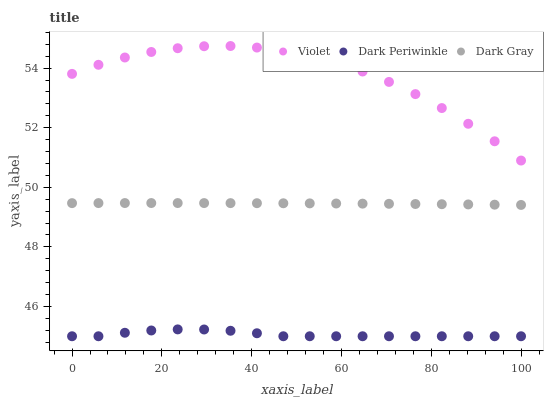Does Dark Periwinkle have the minimum area under the curve?
Answer yes or no. Yes. Does Violet have the maximum area under the curve?
Answer yes or no. Yes. Does Violet have the minimum area under the curve?
Answer yes or no. No. Does Dark Periwinkle have the maximum area under the curve?
Answer yes or no. No. Is Dark Gray the smoothest?
Answer yes or no. Yes. Is Violet the roughest?
Answer yes or no. Yes. Is Dark Periwinkle the smoothest?
Answer yes or no. No. Is Dark Periwinkle the roughest?
Answer yes or no. No. Does Dark Periwinkle have the lowest value?
Answer yes or no. Yes. Does Violet have the lowest value?
Answer yes or no. No. Does Violet have the highest value?
Answer yes or no. Yes. Does Dark Periwinkle have the highest value?
Answer yes or no. No. Is Dark Periwinkle less than Violet?
Answer yes or no. Yes. Is Violet greater than Dark Periwinkle?
Answer yes or no. Yes. Does Dark Periwinkle intersect Violet?
Answer yes or no. No. 